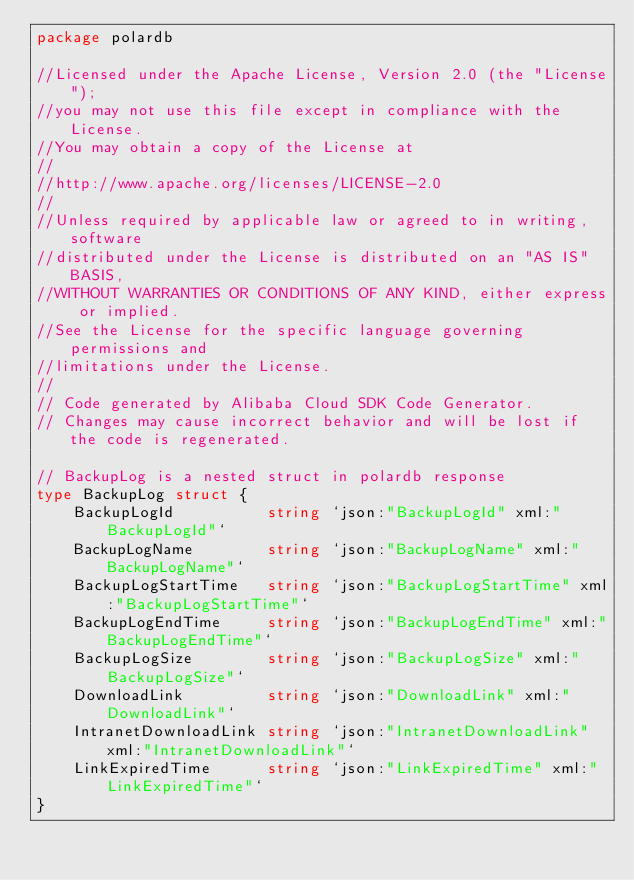<code> <loc_0><loc_0><loc_500><loc_500><_Go_>package polardb

//Licensed under the Apache License, Version 2.0 (the "License");
//you may not use this file except in compliance with the License.
//You may obtain a copy of the License at
//
//http://www.apache.org/licenses/LICENSE-2.0
//
//Unless required by applicable law or agreed to in writing, software
//distributed under the License is distributed on an "AS IS" BASIS,
//WITHOUT WARRANTIES OR CONDITIONS OF ANY KIND, either express or implied.
//See the License for the specific language governing permissions and
//limitations under the License.
//
// Code generated by Alibaba Cloud SDK Code Generator.
// Changes may cause incorrect behavior and will be lost if the code is regenerated.

// BackupLog is a nested struct in polardb response
type BackupLog struct {
	BackupLogId          string `json:"BackupLogId" xml:"BackupLogId"`
	BackupLogName        string `json:"BackupLogName" xml:"BackupLogName"`
	BackupLogStartTime   string `json:"BackupLogStartTime" xml:"BackupLogStartTime"`
	BackupLogEndTime     string `json:"BackupLogEndTime" xml:"BackupLogEndTime"`
	BackupLogSize        string `json:"BackupLogSize" xml:"BackupLogSize"`
	DownloadLink         string `json:"DownloadLink" xml:"DownloadLink"`
	IntranetDownloadLink string `json:"IntranetDownloadLink" xml:"IntranetDownloadLink"`
	LinkExpiredTime      string `json:"LinkExpiredTime" xml:"LinkExpiredTime"`
}
</code> 